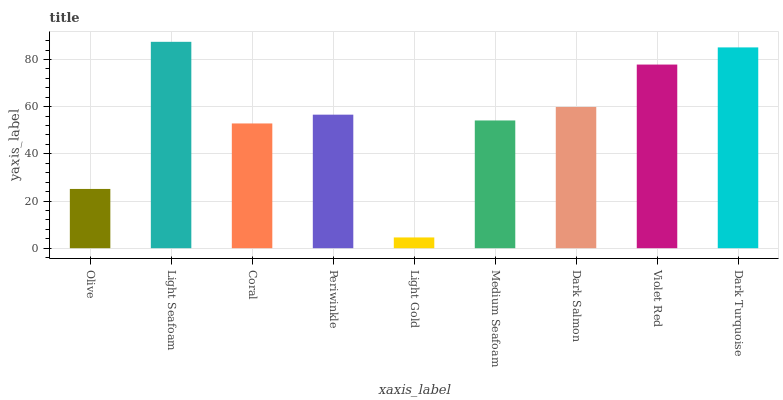Is Light Gold the minimum?
Answer yes or no. Yes. Is Light Seafoam the maximum?
Answer yes or no. Yes. Is Coral the minimum?
Answer yes or no. No. Is Coral the maximum?
Answer yes or no. No. Is Light Seafoam greater than Coral?
Answer yes or no. Yes. Is Coral less than Light Seafoam?
Answer yes or no. Yes. Is Coral greater than Light Seafoam?
Answer yes or no. No. Is Light Seafoam less than Coral?
Answer yes or no. No. Is Periwinkle the high median?
Answer yes or no. Yes. Is Periwinkle the low median?
Answer yes or no. Yes. Is Olive the high median?
Answer yes or no. No. Is Coral the low median?
Answer yes or no. No. 